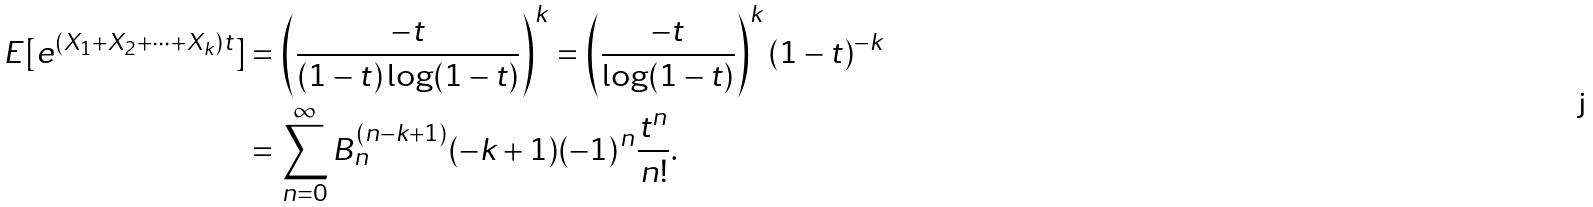Convert formula to latex. <formula><loc_0><loc_0><loc_500><loc_500>E [ e ^ { ( X _ { 1 } + X _ { 2 } + \cdots + X _ { k } ) t } ] & = \left ( \frac { - t } { ( 1 - t ) \log ( 1 - t ) } \right ) ^ { k } = \left ( \frac { - t } { \log ( 1 - t ) } \right ) ^ { k } ( 1 - t ) ^ { - k } \\ & = \sum _ { n = 0 } ^ { \infty } B _ { n } ^ { ( n - k + 1 ) } ( - k + 1 ) ( - 1 ) ^ { n } \frac { t ^ { n } } { n ! } .</formula> 